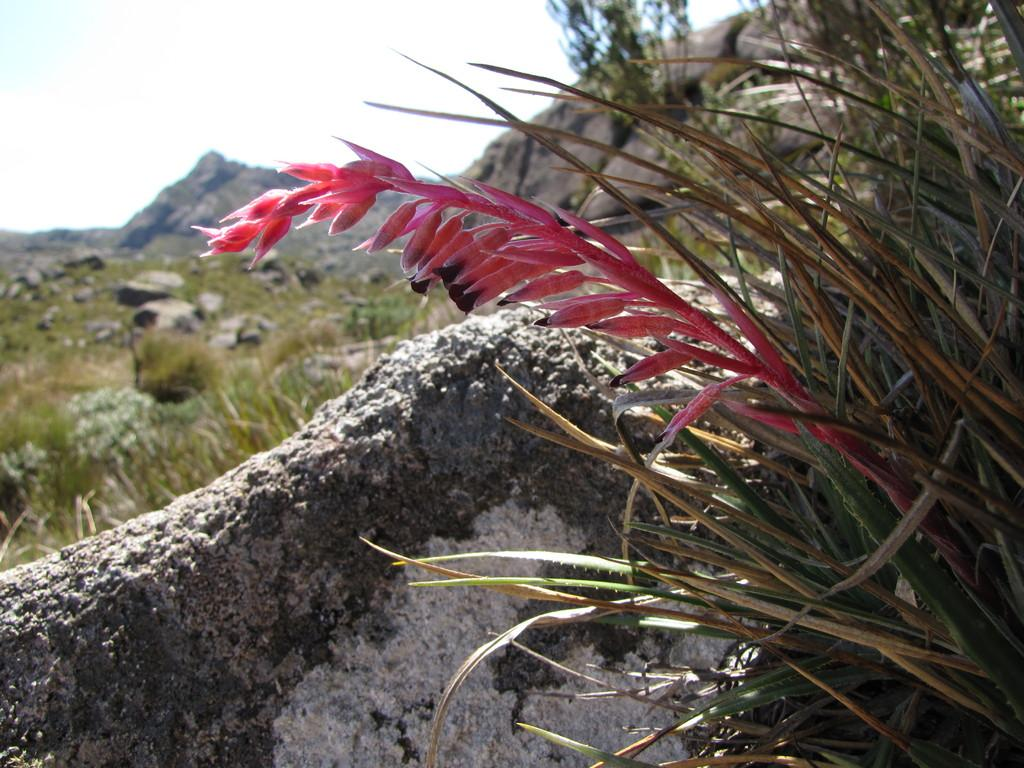What type of natural landscape is depicted in the image? The image features mountains. What other geological features can be seen in the image? There are rocks visible in the image. What part of the natural environment is visible in the image? The sky is visible in the image. What type of vegetation is present in the image? There are plants and grass visible in the image. Can you see a wave crashing on the shore in the image? There is no wave or shore present in the image; it features mountains, rocks, the sky, plants, and grass. What type of plant is rolling down the hill in the image? There is no plant rolling down the hill in the image; it features mountains, rocks, the sky, plants, and grass. 